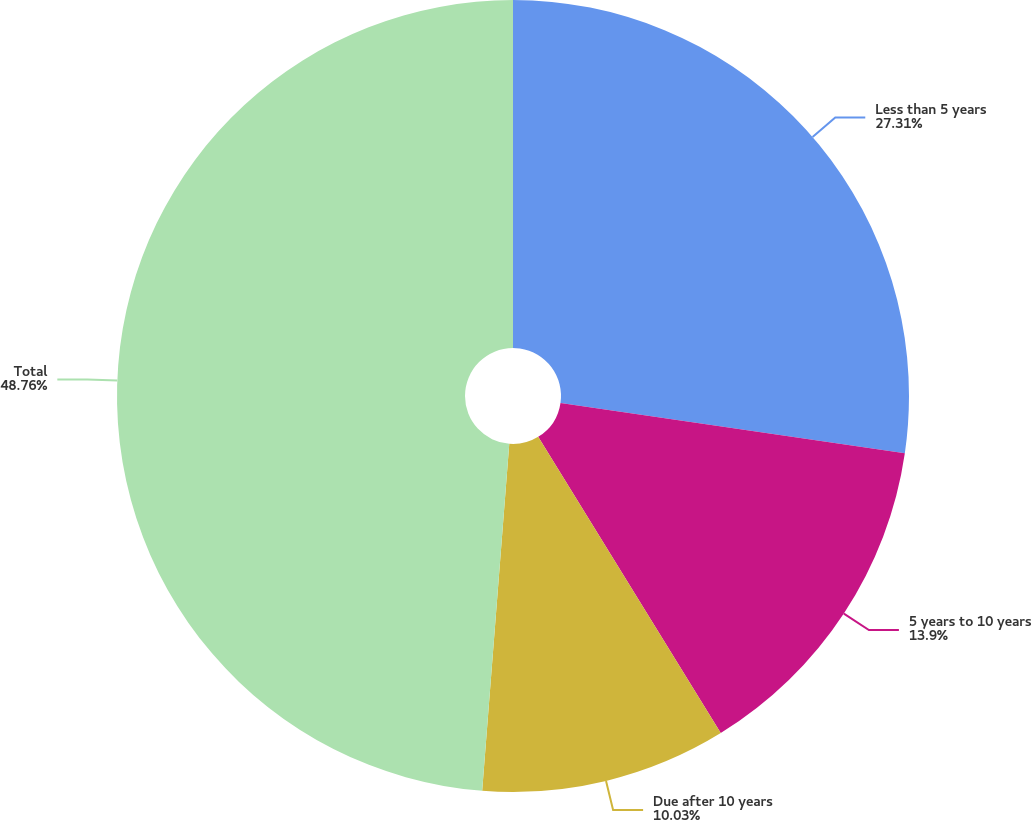<chart> <loc_0><loc_0><loc_500><loc_500><pie_chart><fcel>Less than 5 years<fcel>5 years to 10 years<fcel>Due after 10 years<fcel>Total<nl><fcel>27.31%<fcel>13.9%<fcel>10.03%<fcel>48.76%<nl></chart> 